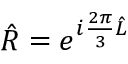<formula> <loc_0><loc_0><loc_500><loc_500>\hat { R } = e ^ { i \frac { 2 \pi } { 3 } \hat { L } }</formula> 